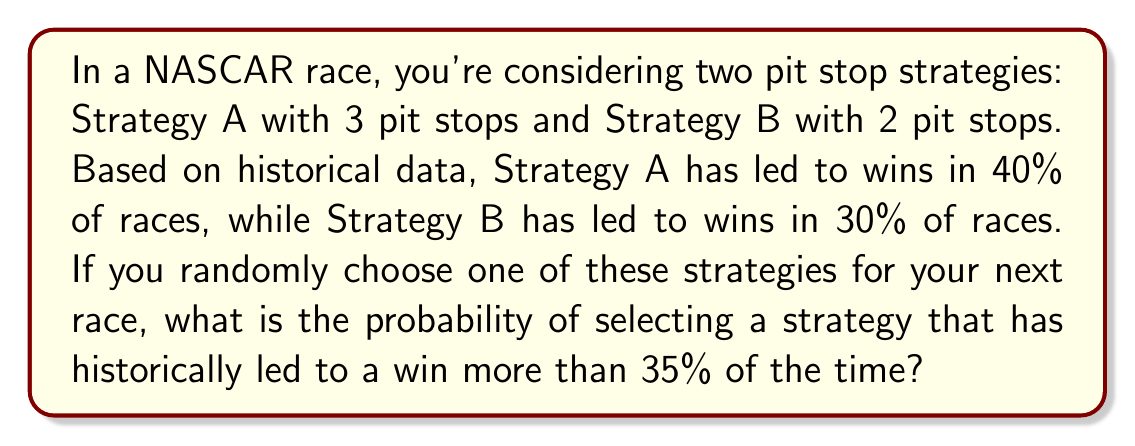Help me with this question. Let's approach this step-by-step:

1) First, we need to identify which strategy meets the criteria of winning more than 35% of the time:
   - Strategy A: 40% > 35%
   - Strategy B: 30% < 35%

   Only Strategy A meets this criterion.

2) Now, we need to calculate the probability of choosing Strategy A:
   - There are two strategies in total
   - The probability of choosing any one strategy is $\frac{1}{2}$ or 0.5

3) Since only Strategy A meets our criteria, and the probability of choosing Strategy A is $\frac{1}{2}$, this is our final answer.

4) We can express this probability as a percentage:
   $\frac{1}{2} \times 100\% = 50\%$

Therefore, the probability of selecting a strategy that has historically led to a win more than 35% of the time is 50%.
Answer: $\frac{1}{2}$ or 50% 